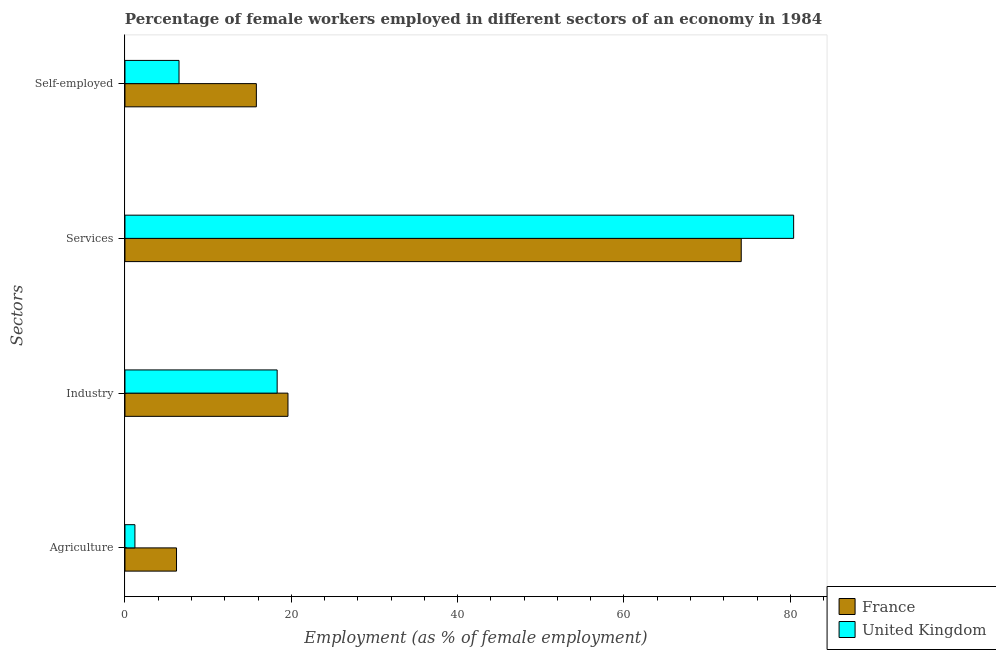Are the number of bars per tick equal to the number of legend labels?
Your answer should be very brief. Yes. Are the number of bars on each tick of the Y-axis equal?
Keep it short and to the point. Yes. How many bars are there on the 4th tick from the top?
Give a very brief answer. 2. What is the label of the 4th group of bars from the top?
Your response must be concise. Agriculture. Across all countries, what is the maximum percentage of female workers in industry?
Keep it short and to the point. 19.6. Across all countries, what is the minimum percentage of female workers in services?
Your answer should be compact. 74.1. In which country was the percentage of female workers in agriculture maximum?
Give a very brief answer. France. In which country was the percentage of female workers in agriculture minimum?
Your response must be concise. United Kingdom. What is the total percentage of female workers in services in the graph?
Provide a succinct answer. 154.5. What is the difference between the percentage of female workers in industry in France and that in United Kingdom?
Ensure brevity in your answer.  1.3. What is the difference between the percentage of female workers in services in United Kingdom and the percentage of female workers in industry in France?
Give a very brief answer. 60.8. What is the average percentage of self employed female workers per country?
Make the answer very short. 11.15. What is the difference between the percentage of self employed female workers and percentage of female workers in industry in United Kingdom?
Offer a terse response. -11.8. What is the ratio of the percentage of self employed female workers in United Kingdom to that in France?
Your answer should be very brief. 0.41. Is the difference between the percentage of female workers in agriculture in France and United Kingdom greater than the difference between the percentage of female workers in services in France and United Kingdom?
Offer a very short reply. Yes. What is the difference between the highest and the second highest percentage of female workers in services?
Your answer should be very brief. 6.3. What is the difference between the highest and the lowest percentage of female workers in services?
Your answer should be very brief. 6.3. Is it the case that in every country, the sum of the percentage of female workers in industry and percentage of self employed female workers is greater than the sum of percentage of female workers in services and percentage of female workers in agriculture?
Provide a short and direct response. No. What does the 1st bar from the top in Agriculture represents?
Keep it short and to the point. United Kingdom. What does the 2nd bar from the bottom in Services represents?
Provide a short and direct response. United Kingdom. How many bars are there?
Your answer should be compact. 8. How many countries are there in the graph?
Make the answer very short. 2. What is the difference between two consecutive major ticks on the X-axis?
Your response must be concise. 20. Are the values on the major ticks of X-axis written in scientific E-notation?
Offer a terse response. No. Does the graph contain any zero values?
Offer a terse response. No. How many legend labels are there?
Keep it short and to the point. 2. What is the title of the graph?
Give a very brief answer. Percentage of female workers employed in different sectors of an economy in 1984. What is the label or title of the X-axis?
Your answer should be compact. Employment (as % of female employment). What is the label or title of the Y-axis?
Ensure brevity in your answer.  Sectors. What is the Employment (as % of female employment) of France in Agriculture?
Your answer should be very brief. 6.2. What is the Employment (as % of female employment) in United Kingdom in Agriculture?
Keep it short and to the point. 1.2. What is the Employment (as % of female employment) of France in Industry?
Your response must be concise. 19.6. What is the Employment (as % of female employment) of United Kingdom in Industry?
Your response must be concise. 18.3. What is the Employment (as % of female employment) of France in Services?
Your response must be concise. 74.1. What is the Employment (as % of female employment) in United Kingdom in Services?
Keep it short and to the point. 80.4. What is the Employment (as % of female employment) of France in Self-employed?
Provide a succinct answer. 15.8. Across all Sectors, what is the maximum Employment (as % of female employment) in France?
Offer a terse response. 74.1. Across all Sectors, what is the maximum Employment (as % of female employment) of United Kingdom?
Make the answer very short. 80.4. Across all Sectors, what is the minimum Employment (as % of female employment) in France?
Provide a short and direct response. 6.2. Across all Sectors, what is the minimum Employment (as % of female employment) in United Kingdom?
Your answer should be very brief. 1.2. What is the total Employment (as % of female employment) of France in the graph?
Make the answer very short. 115.7. What is the total Employment (as % of female employment) of United Kingdom in the graph?
Provide a short and direct response. 106.4. What is the difference between the Employment (as % of female employment) of France in Agriculture and that in Industry?
Offer a terse response. -13.4. What is the difference between the Employment (as % of female employment) of United Kingdom in Agriculture and that in Industry?
Keep it short and to the point. -17.1. What is the difference between the Employment (as % of female employment) of France in Agriculture and that in Services?
Provide a short and direct response. -67.9. What is the difference between the Employment (as % of female employment) of United Kingdom in Agriculture and that in Services?
Ensure brevity in your answer.  -79.2. What is the difference between the Employment (as % of female employment) of France in Agriculture and that in Self-employed?
Ensure brevity in your answer.  -9.6. What is the difference between the Employment (as % of female employment) of France in Industry and that in Services?
Your response must be concise. -54.5. What is the difference between the Employment (as % of female employment) of United Kingdom in Industry and that in Services?
Offer a terse response. -62.1. What is the difference between the Employment (as % of female employment) of France in Industry and that in Self-employed?
Offer a very short reply. 3.8. What is the difference between the Employment (as % of female employment) of France in Services and that in Self-employed?
Make the answer very short. 58.3. What is the difference between the Employment (as % of female employment) of United Kingdom in Services and that in Self-employed?
Offer a terse response. 73.9. What is the difference between the Employment (as % of female employment) in France in Agriculture and the Employment (as % of female employment) in United Kingdom in Services?
Your answer should be very brief. -74.2. What is the difference between the Employment (as % of female employment) of France in Industry and the Employment (as % of female employment) of United Kingdom in Services?
Keep it short and to the point. -60.8. What is the difference between the Employment (as % of female employment) of France in Services and the Employment (as % of female employment) of United Kingdom in Self-employed?
Keep it short and to the point. 67.6. What is the average Employment (as % of female employment) in France per Sectors?
Provide a succinct answer. 28.93. What is the average Employment (as % of female employment) in United Kingdom per Sectors?
Your answer should be compact. 26.6. What is the difference between the Employment (as % of female employment) in France and Employment (as % of female employment) in United Kingdom in Agriculture?
Your answer should be very brief. 5. What is the difference between the Employment (as % of female employment) of France and Employment (as % of female employment) of United Kingdom in Industry?
Offer a terse response. 1.3. What is the difference between the Employment (as % of female employment) of France and Employment (as % of female employment) of United Kingdom in Services?
Provide a short and direct response. -6.3. What is the ratio of the Employment (as % of female employment) in France in Agriculture to that in Industry?
Ensure brevity in your answer.  0.32. What is the ratio of the Employment (as % of female employment) of United Kingdom in Agriculture to that in Industry?
Provide a succinct answer. 0.07. What is the ratio of the Employment (as % of female employment) in France in Agriculture to that in Services?
Give a very brief answer. 0.08. What is the ratio of the Employment (as % of female employment) in United Kingdom in Agriculture to that in Services?
Provide a succinct answer. 0.01. What is the ratio of the Employment (as % of female employment) of France in Agriculture to that in Self-employed?
Your answer should be very brief. 0.39. What is the ratio of the Employment (as % of female employment) in United Kingdom in Agriculture to that in Self-employed?
Provide a short and direct response. 0.18. What is the ratio of the Employment (as % of female employment) in France in Industry to that in Services?
Keep it short and to the point. 0.26. What is the ratio of the Employment (as % of female employment) of United Kingdom in Industry to that in Services?
Offer a terse response. 0.23. What is the ratio of the Employment (as % of female employment) in France in Industry to that in Self-employed?
Your response must be concise. 1.24. What is the ratio of the Employment (as % of female employment) of United Kingdom in Industry to that in Self-employed?
Your answer should be compact. 2.82. What is the ratio of the Employment (as % of female employment) of France in Services to that in Self-employed?
Ensure brevity in your answer.  4.69. What is the ratio of the Employment (as % of female employment) in United Kingdom in Services to that in Self-employed?
Provide a short and direct response. 12.37. What is the difference between the highest and the second highest Employment (as % of female employment) in France?
Make the answer very short. 54.5. What is the difference between the highest and the second highest Employment (as % of female employment) of United Kingdom?
Your answer should be very brief. 62.1. What is the difference between the highest and the lowest Employment (as % of female employment) of France?
Your answer should be compact. 67.9. What is the difference between the highest and the lowest Employment (as % of female employment) of United Kingdom?
Provide a succinct answer. 79.2. 